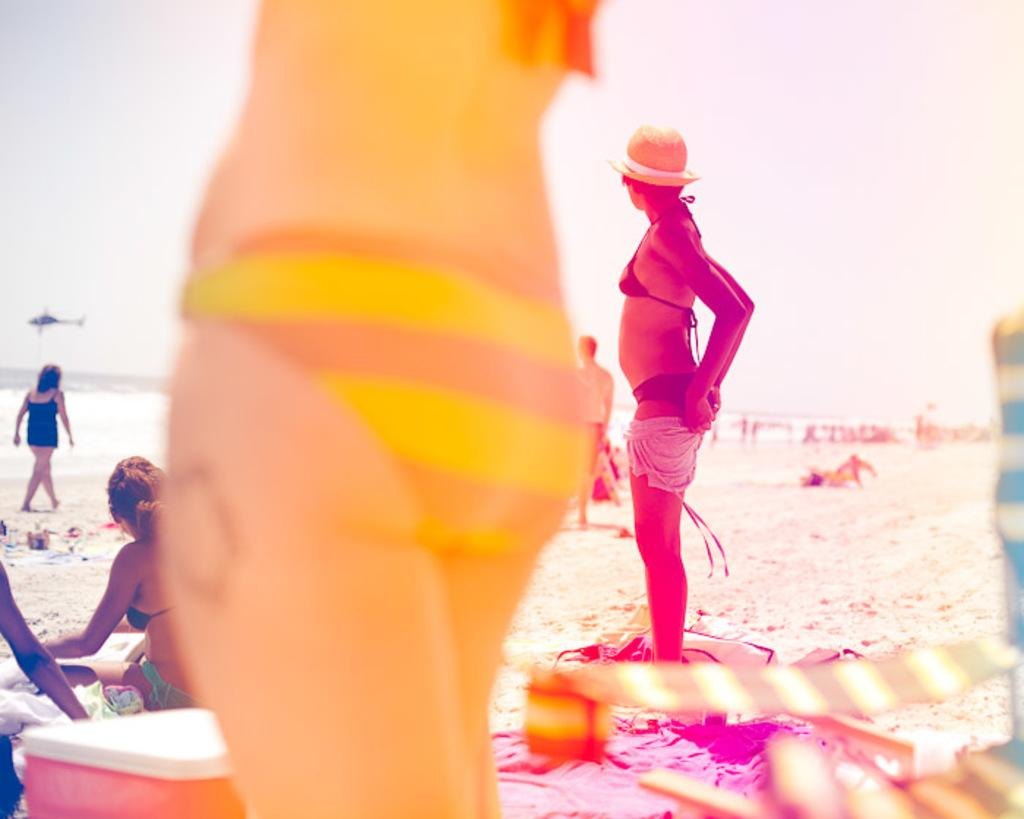What is the location of the people in the image? The people are on the sea shore. What is flying over the water in the image? There is a plane over the water in the image. What type of furniture can be seen in the image? Chairs are present in the image. What object is in the shape of a cube in the image? There is a box in the image. What part of the natural environment is visible in the image? The sky is visible in the image. What type of quarter is visible in the image? There is no quarter present in the image. What industry can be seen operating on the sea shore in the image? There is no industry visible in the image; it features people on the sea shore and a plane over the water. 